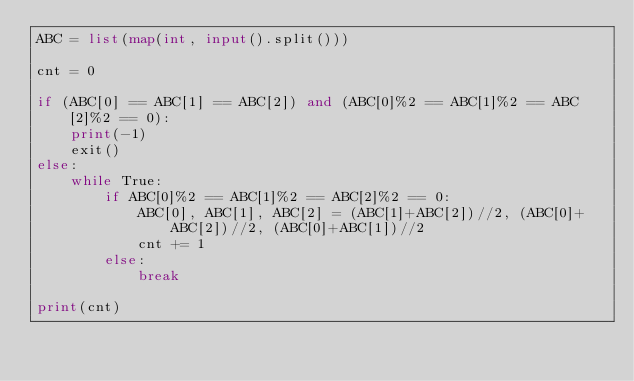<code> <loc_0><loc_0><loc_500><loc_500><_Python_>ABC = list(map(int, input().split()))

cnt = 0

if (ABC[0] == ABC[1] == ABC[2]) and (ABC[0]%2 == ABC[1]%2 == ABC[2]%2 == 0):
    print(-1)
    exit()
else:
    while True:
        if ABC[0]%2 == ABC[1]%2 == ABC[2]%2 == 0:
            ABC[0], ABC[1], ABC[2] = (ABC[1]+ABC[2])//2, (ABC[0]+ABC[2])//2, (ABC[0]+ABC[1])//2
            cnt += 1
        else:
            break
 
print(cnt)</code> 